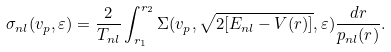<formula> <loc_0><loc_0><loc_500><loc_500>\sigma _ { n l } ( v _ { p } , \varepsilon ) = \frac { 2 } { T _ { n l } } \int _ { r _ { 1 } } ^ { r _ { 2 } } \Sigma ( v _ { p } , \sqrt { 2 [ E _ { n l } - V ( r ) ] } , \varepsilon ) \frac { d r } { p _ { n l } ( r ) } .</formula> 